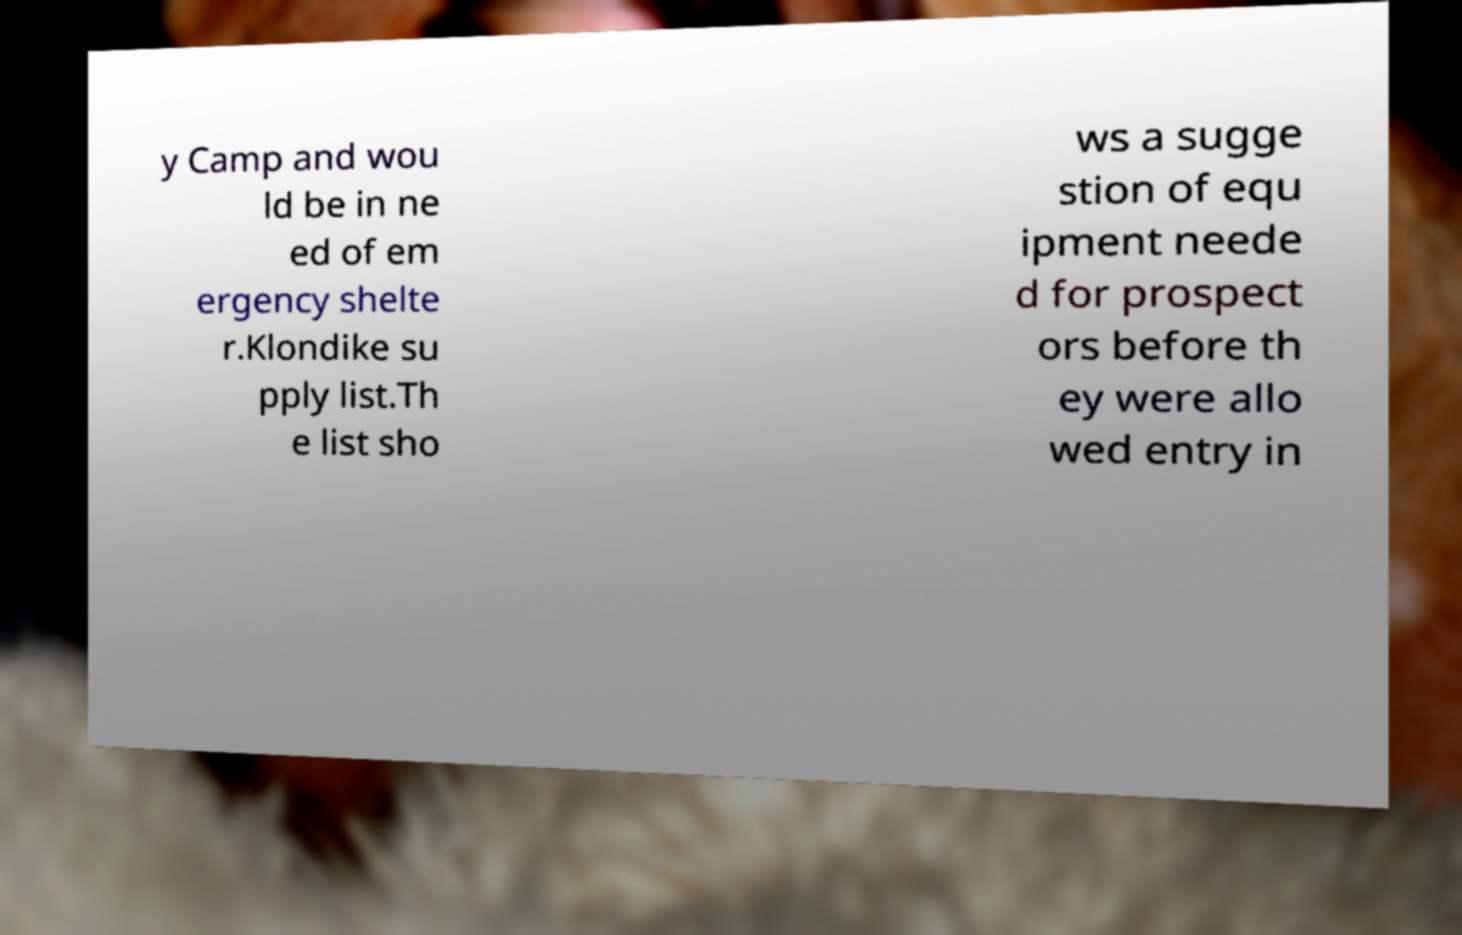Can you accurately transcribe the text from the provided image for me? y Camp and wou ld be in ne ed of em ergency shelte r.Klondike su pply list.Th e list sho ws a sugge stion of equ ipment neede d for prospect ors before th ey were allo wed entry in 